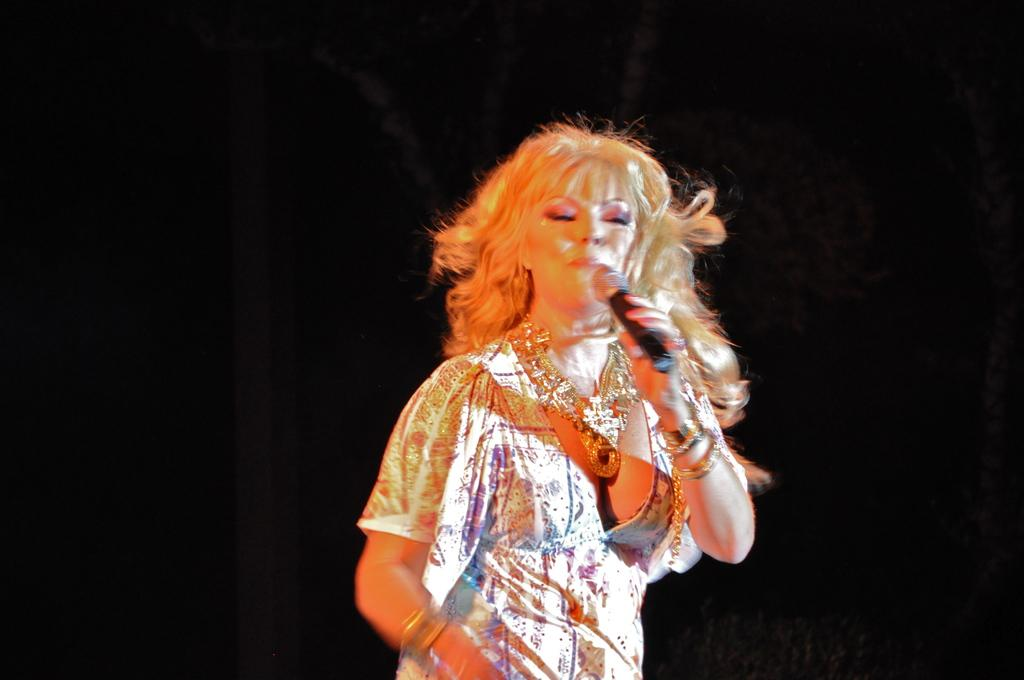Who is the main subject in the image? There is a woman in the image. What is the woman doing in the image? The woman is singing. What object is the woman holding in her hand? The woman is holding a mic in her hand. Can you see a tiger in the image? No, there is no tiger present in the image. 